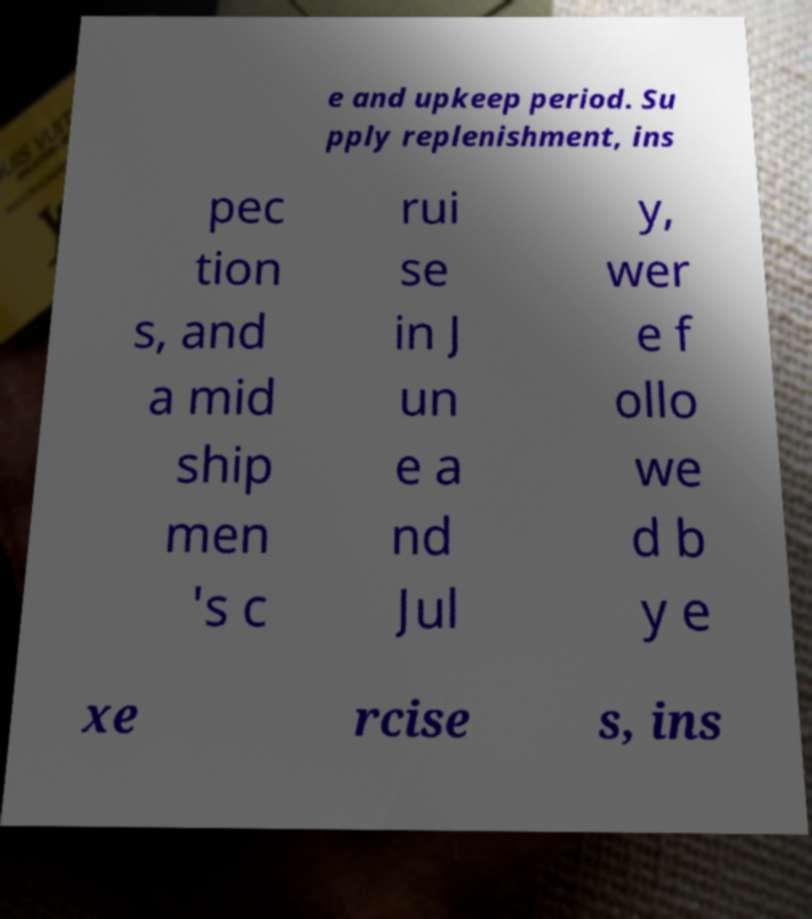Please identify and transcribe the text found in this image. e and upkeep period. Su pply replenishment, ins pec tion s, and a mid ship men 's c rui se in J un e a nd Jul y, wer e f ollo we d b y e xe rcise s, ins 